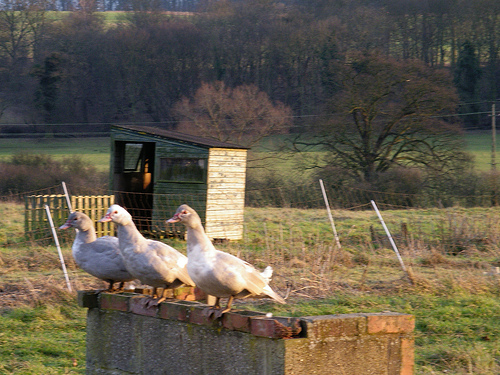<image>
Can you confirm if the duck is to the left of the duck? Yes. From this viewpoint, the duck is positioned to the left side relative to the duck. Where is the duck in relation to the shed? Is it in front of the shed? No. The duck is not in front of the shed. The spatial positioning shows a different relationship between these objects. 